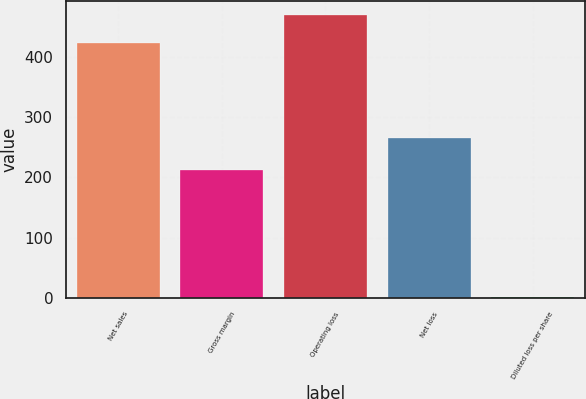Convert chart. <chart><loc_0><loc_0><loc_500><loc_500><bar_chart><fcel>Net sales<fcel>Gross margin<fcel>Operating loss<fcel>Net loss<fcel>Diluted loss per share<nl><fcel>423.9<fcel>212.6<fcel>469.06<fcel>265.9<fcel>0.44<nl></chart> 